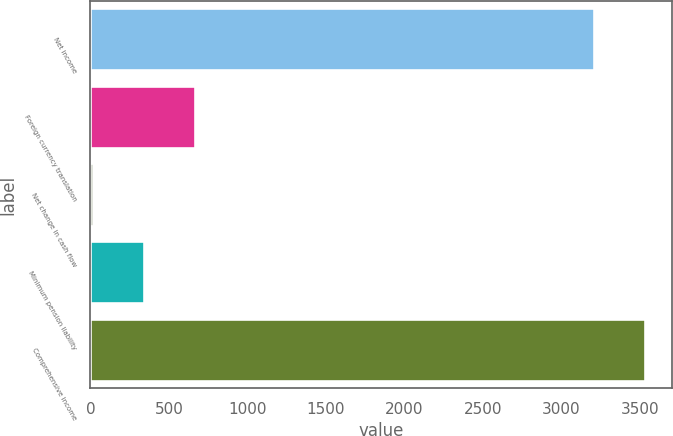Convert chart to OTSL. <chart><loc_0><loc_0><loc_500><loc_500><bar_chart><fcel>Net income<fcel>Foreign currency translation<fcel>Net change in cash flow<fcel>Minimum pension liability<fcel>Comprehensive income<nl><fcel>3209<fcel>665.8<fcel>19<fcel>342.4<fcel>3532.4<nl></chart> 